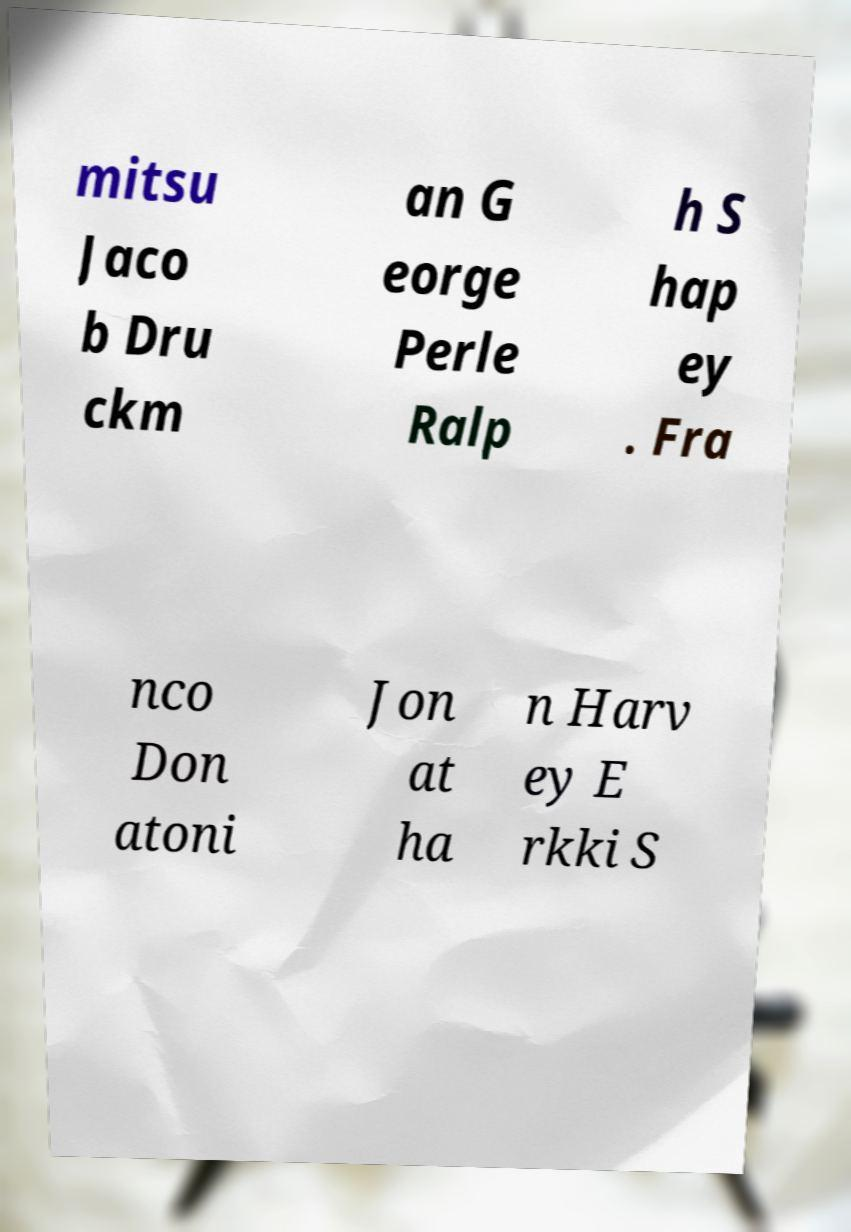Could you extract and type out the text from this image? mitsu Jaco b Dru ckm an G eorge Perle Ralp h S hap ey . Fra nco Don atoni Jon at ha n Harv ey E rkki S 